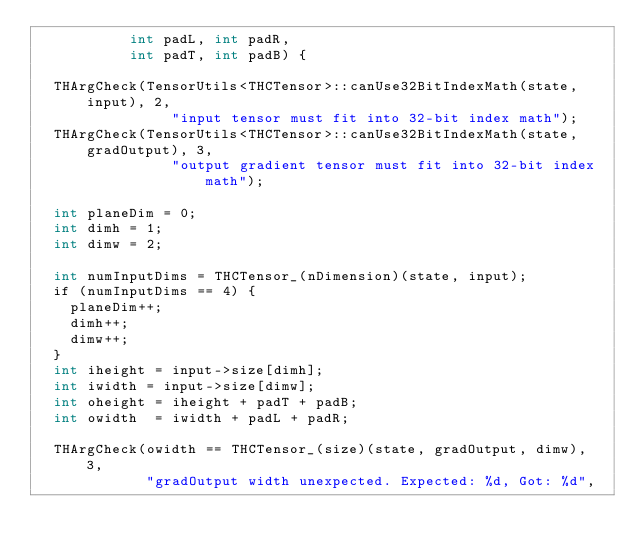Convert code to text. <code><loc_0><loc_0><loc_500><loc_500><_Cuda_>           int padL, int padR,
           int padT, int padB) {

  THArgCheck(TensorUtils<THCTensor>::canUse32BitIndexMath(state, input), 2,
                "input tensor must fit into 32-bit index math");
  THArgCheck(TensorUtils<THCTensor>::canUse32BitIndexMath(state, gradOutput), 3,
                "output gradient tensor must fit into 32-bit index math");

  int planeDim = 0;
  int dimh = 1;
  int dimw = 2;

  int numInputDims = THCTensor_(nDimension)(state, input);
  if (numInputDims == 4) {
    planeDim++;
    dimh++;
    dimw++;
  }
  int iheight = input->size[dimh];
  int iwidth = input->size[dimw];
  int oheight = iheight + padT + padB;
  int owidth  = iwidth + padL + padR;

  THArgCheck(owidth == THCTensor_(size)(state, gradOutput, dimw), 3,
             "gradOutput width unexpected. Expected: %d, Got: %d",</code> 